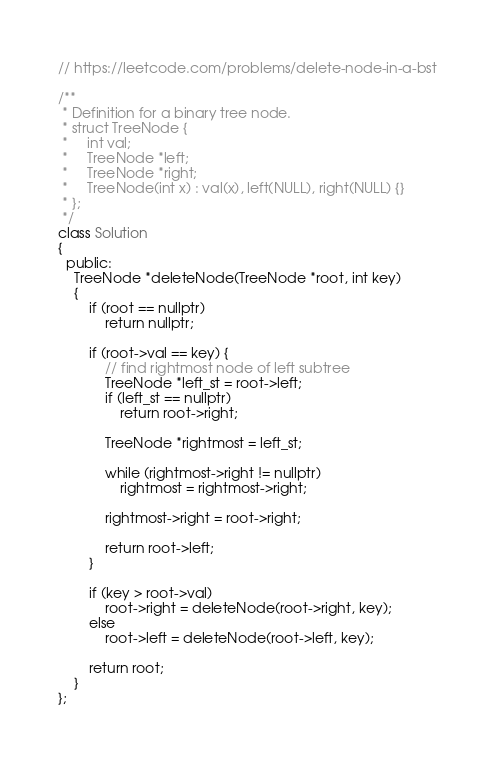<code> <loc_0><loc_0><loc_500><loc_500><_C++_>// https://leetcode.com/problems/delete-node-in-a-bst

/**
 * Definition for a binary tree node.
 * struct TreeNode {
 *     int val;
 *     TreeNode *left;
 *     TreeNode *right;
 *     TreeNode(int x) : val(x), left(NULL), right(NULL) {}
 * };
 */
class Solution
{
  public:
    TreeNode *deleteNode(TreeNode *root, int key)
    {
        if (root == nullptr)
            return nullptr;

        if (root->val == key) {
            // find rightmost node of left subtree
            TreeNode *left_st = root->left;
            if (left_st == nullptr)
                return root->right;

            TreeNode *rightmost = left_st;

            while (rightmost->right != nullptr)
                rightmost = rightmost->right;

            rightmost->right = root->right;

            return root->left;
        }

        if (key > root->val)
            root->right = deleteNode(root->right, key);
        else
            root->left = deleteNode(root->left, key);

        return root;
    }
};</code> 